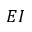<formula> <loc_0><loc_0><loc_500><loc_500>E I</formula> 